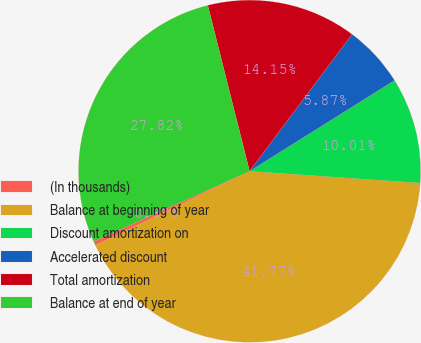Convert chart. <chart><loc_0><loc_0><loc_500><loc_500><pie_chart><fcel>(In thousands)<fcel>Balance at beginning of year<fcel>Discount amortization on<fcel>Accelerated discount<fcel>Total amortization<fcel>Balance at end of year<nl><fcel>0.37%<fcel>41.77%<fcel>10.01%<fcel>5.87%<fcel>14.15%<fcel>27.82%<nl></chart> 